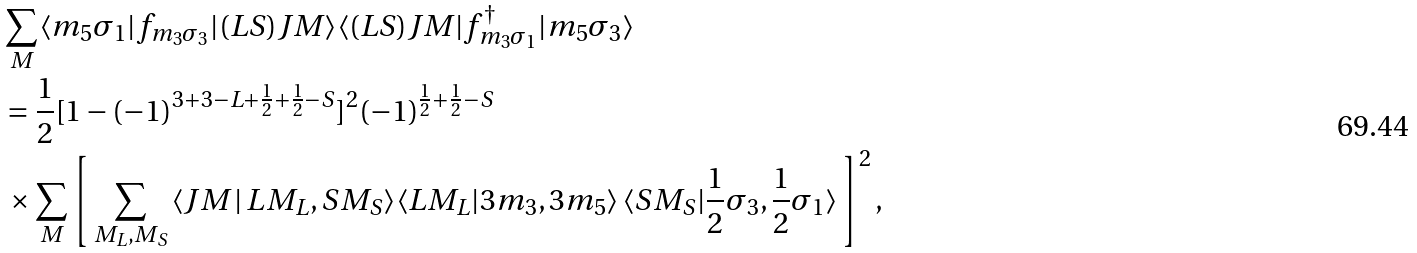Convert formula to latex. <formula><loc_0><loc_0><loc_500><loc_500>& \sum _ { M } \langle m _ { 5 } \sigma _ { 1 } | f _ { m _ { 3 } \sigma _ { 3 } } | ( L S ) J M \rangle \langle ( L S ) J M | f _ { m _ { 3 } \sigma _ { 1 } } ^ { \dagger } | m _ { 5 } \sigma _ { 3 } \rangle \\ & = \frac { 1 } { 2 } [ 1 - ( - 1 ) ^ { 3 + 3 - L + \frac { 1 } { 2 } + \frac { 1 } { 2 } - S } ] ^ { 2 } ( - 1 ) ^ { \frac { 1 } { 2 } + \frac { 1 } { 2 } - S } \\ & \, \times \sum _ { M } \left [ \, \sum _ { M _ { L } , M _ { S } } \, \langle J M \, | \, L M _ { L } , S M _ { S } \rangle \langle L M _ { L } | 3 m _ { 3 } , 3 m _ { 5 } \rangle \, \langle S M _ { S } | \frac { 1 } { 2 } \sigma _ { 3 } , \frac { 1 } { 2 } \sigma _ { 1 } \rangle \, \right ] ^ { 2 } ,</formula> 